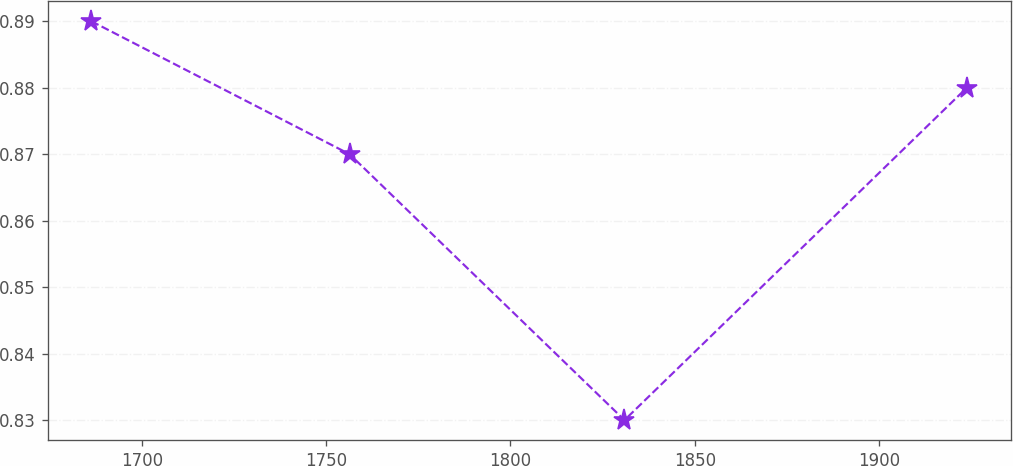Convert chart to OTSL. <chart><loc_0><loc_0><loc_500><loc_500><line_chart><ecel><fcel>Unnamed: 1<nl><fcel>1686.35<fcel>0.89<nl><fcel>1756.38<fcel>0.87<nl><fcel>1830.93<fcel>0.83<nl><fcel>1923.77<fcel>0.88<nl></chart> 